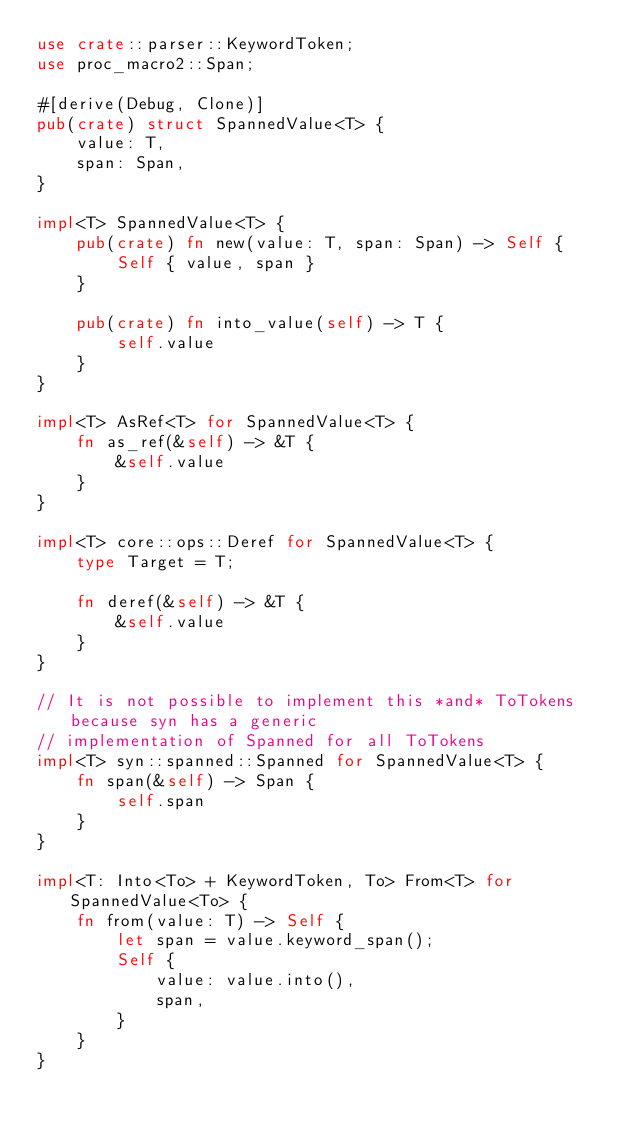Convert code to text. <code><loc_0><loc_0><loc_500><loc_500><_Rust_>use crate::parser::KeywordToken;
use proc_macro2::Span;

#[derive(Debug, Clone)]
pub(crate) struct SpannedValue<T> {
    value: T,
    span: Span,
}

impl<T> SpannedValue<T> {
    pub(crate) fn new(value: T, span: Span) -> Self {
        Self { value, span }
    }

    pub(crate) fn into_value(self) -> T {
        self.value
    }
}

impl<T> AsRef<T> for SpannedValue<T> {
    fn as_ref(&self) -> &T {
        &self.value
    }
}

impl<T> core::ops::Deref for SpannedValue<T> {
    type Target = T;

    fn deref(&self) -> &T {
        &self.value
    }
}

// It is not possible to implement this *and* ToTokens because syn has a generic
// implementation of Spanned for all ToTokens
impl<T> syn::spanned::Spanned for SpannedValue<T> {
    fn span(&self) -> Span {
        self.span
    }
}

impl<T: Into<To> + KeywordToken, To> From<T> for SpannedValue<To> {
    fn from(value: T) -> Self {
        let span = value.keyword_span();
        Self {
            value: value.into(),
            span,
        }
    }
}
</code> 